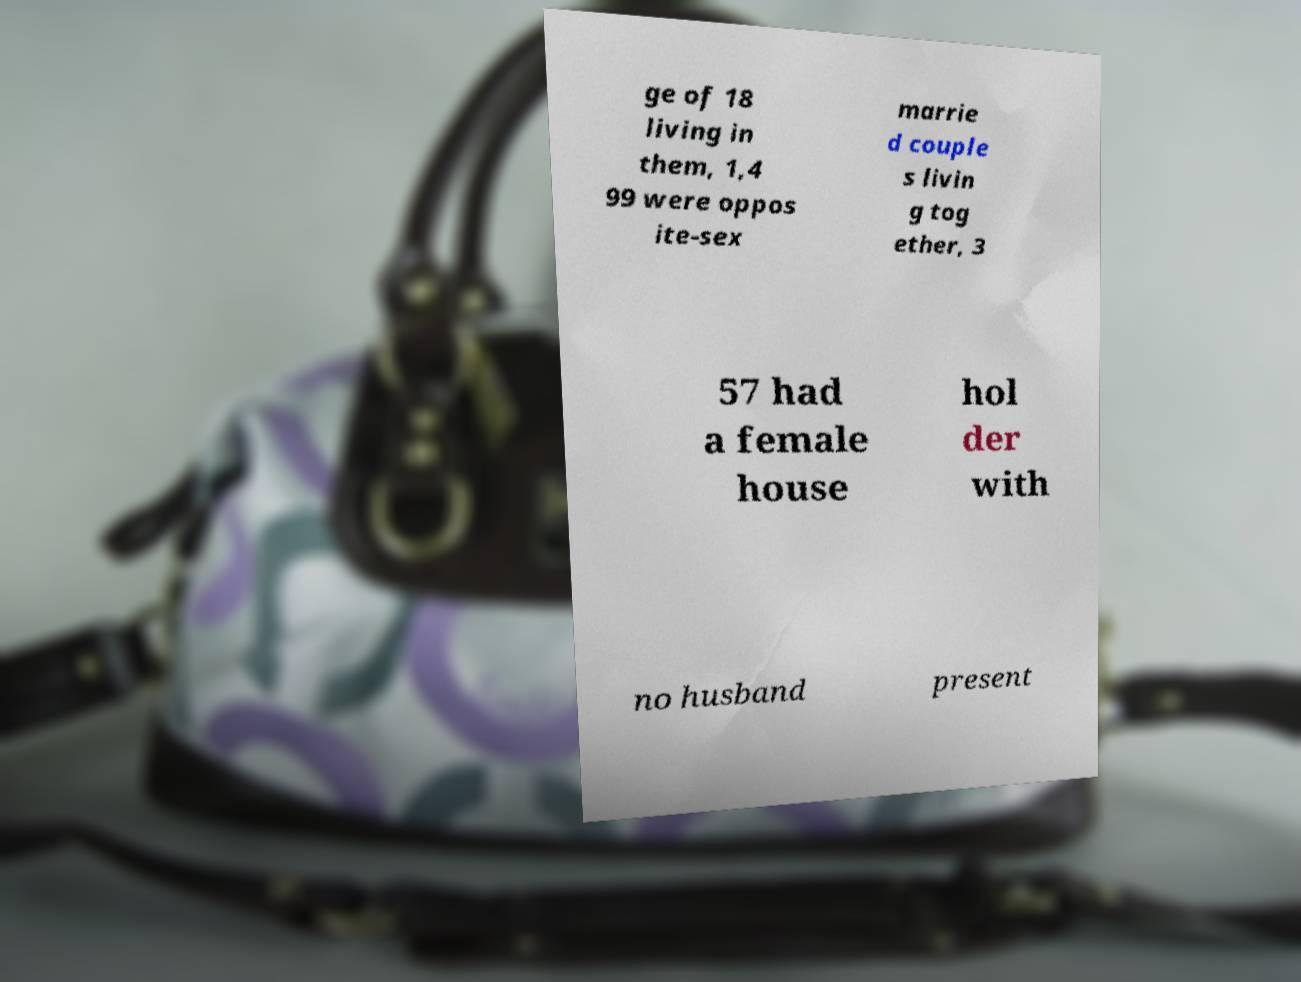For documentation purposes, I need the text within this image transcribed. Could you provide that? ge of 18 living in them, 1,4 99 were oppos ite-sex marrie d couple s livin g tog ether, 3 57 had a female house hol der with no husband present 